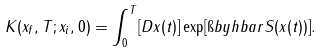Convert formula to latex. <formula><loc_0><loc_0><loc_500><loc_500>K ( x _ { f } , T ; x _ { i } , 0 ) = \int _ { 0 } ^ { T } [ D x ( t ) ] \exp [ \i b y h b a r S ( x ( t ) ) ] .</formula> 